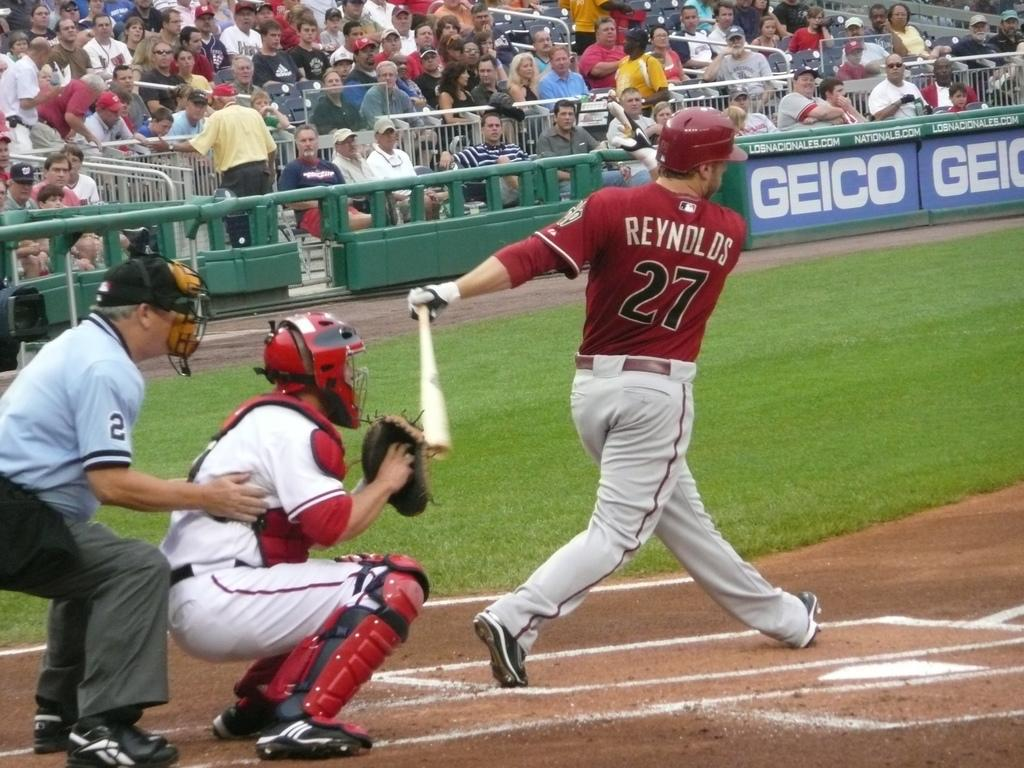<image>
Write a terse but informative summary of the picture. baseball game with a batter of last name Reynolds # 27 hitting the ball at home plate. 